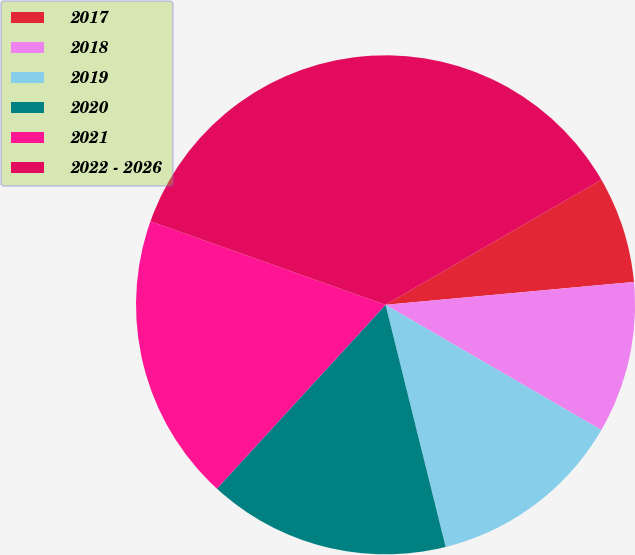Convert chart. <chart><loc_0><loc_0><loc_500><loc_500><pie_chart><fcel>2017<fcel>2018<fcel>2019<fcel>2020<fcel>2021<fcel>2022 - 2026<nl><fcel>6.9%<fcel>9.83%<fcel>12.76%<fcel>15.69%<fcel>18.62%<fcel>36.21%<nl></chart> 